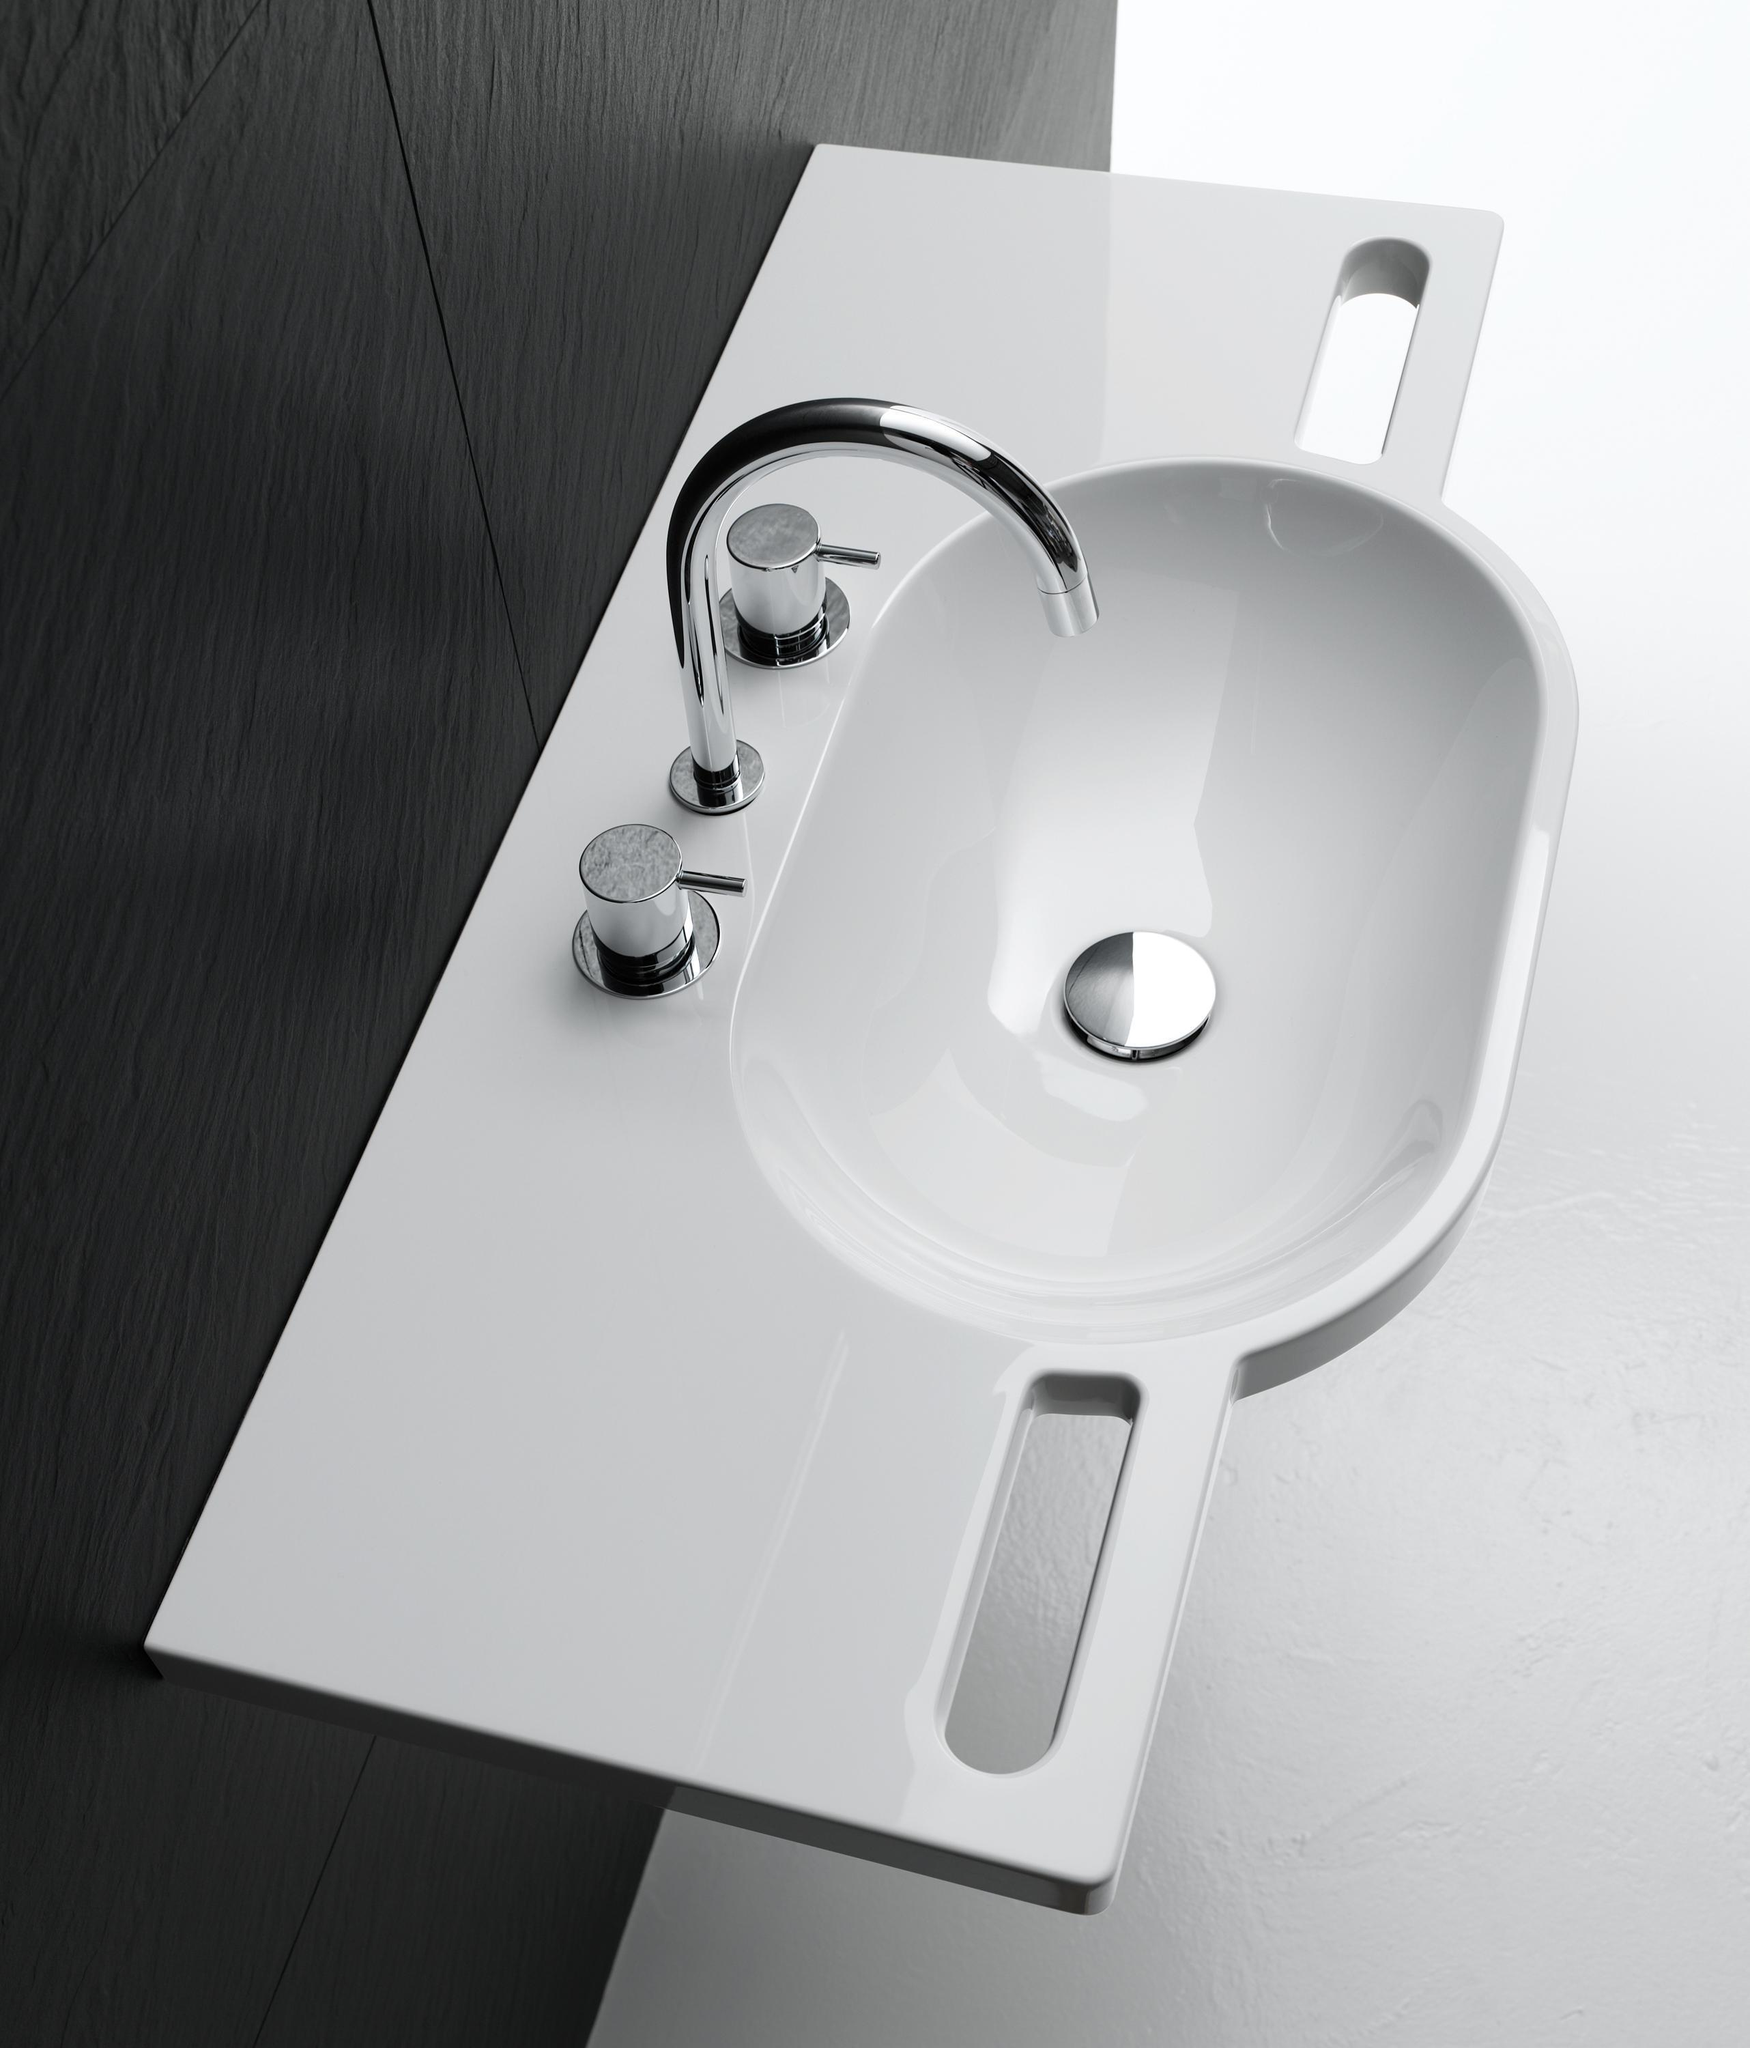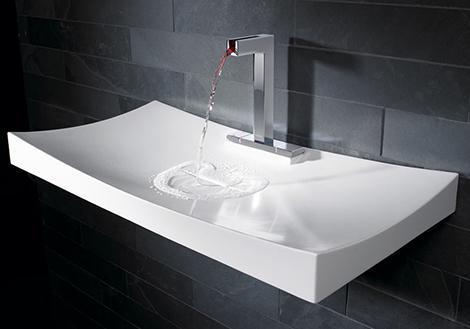The first image is the image on the left, the second image is the image on the right. Examine the images to the left and right. Is the description "One of the sinks is set into a flat counter that is a different color than the sink." accurate? Answer yes or no. No. 